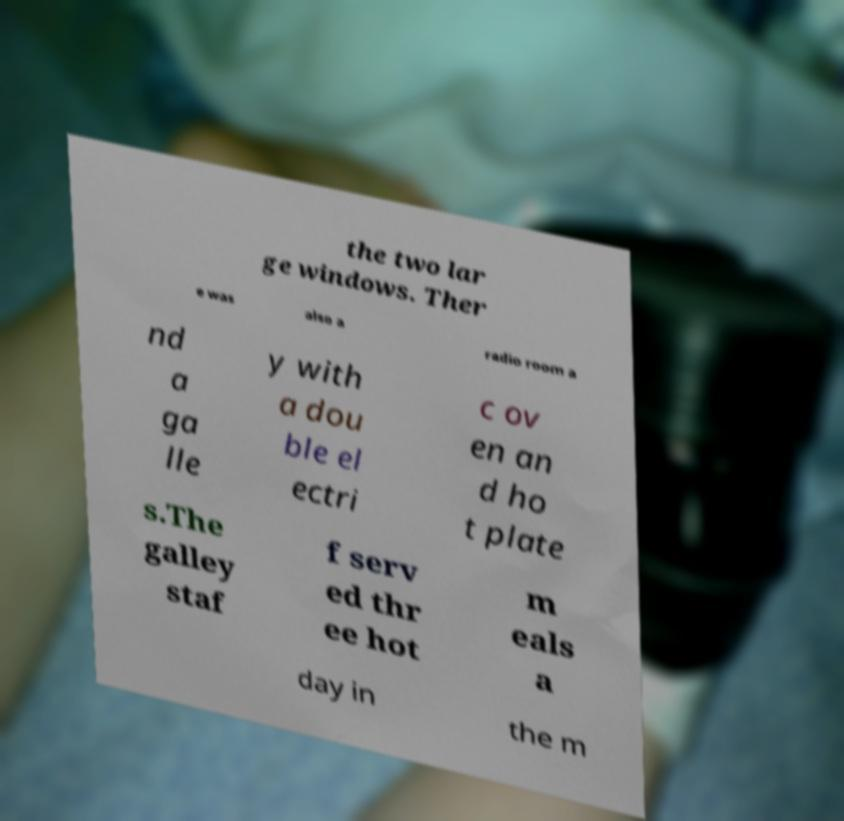Could you assist in decoding the text presented in this image and type it out clearly? the two lar ge windows. Ther e was also a radio room a nd a ga lle y with a dou ble el ectri c ov en an d ho t plate s.The galley staf f serv ed thr ee hot m eals a day in the m 